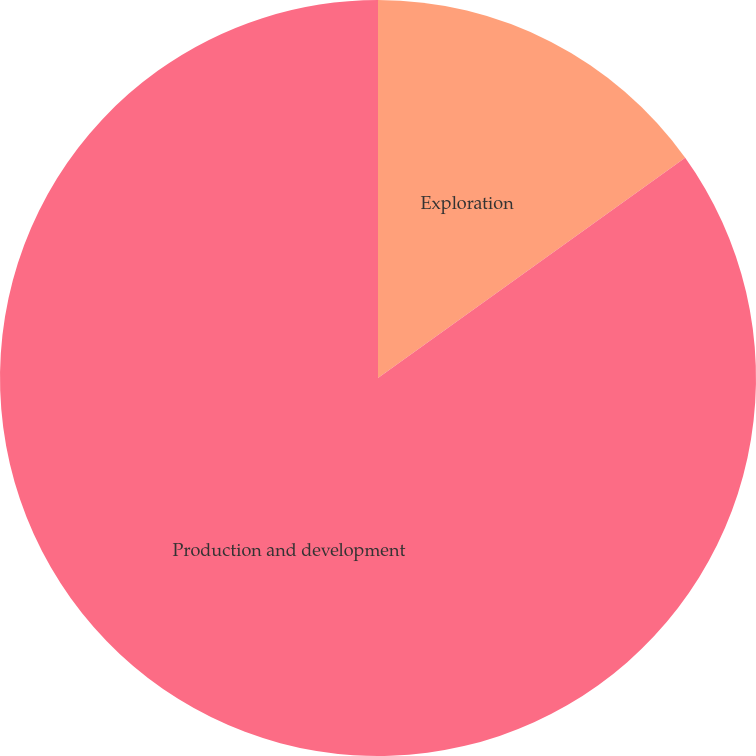Convert chart. <chart><loc_0><loc_0><loc_500><loc_500><pie_chart><fcel>Exploration<fcel>Production and development<nl><fcel>15.1%<fcel>84.9%<nl></chart> 